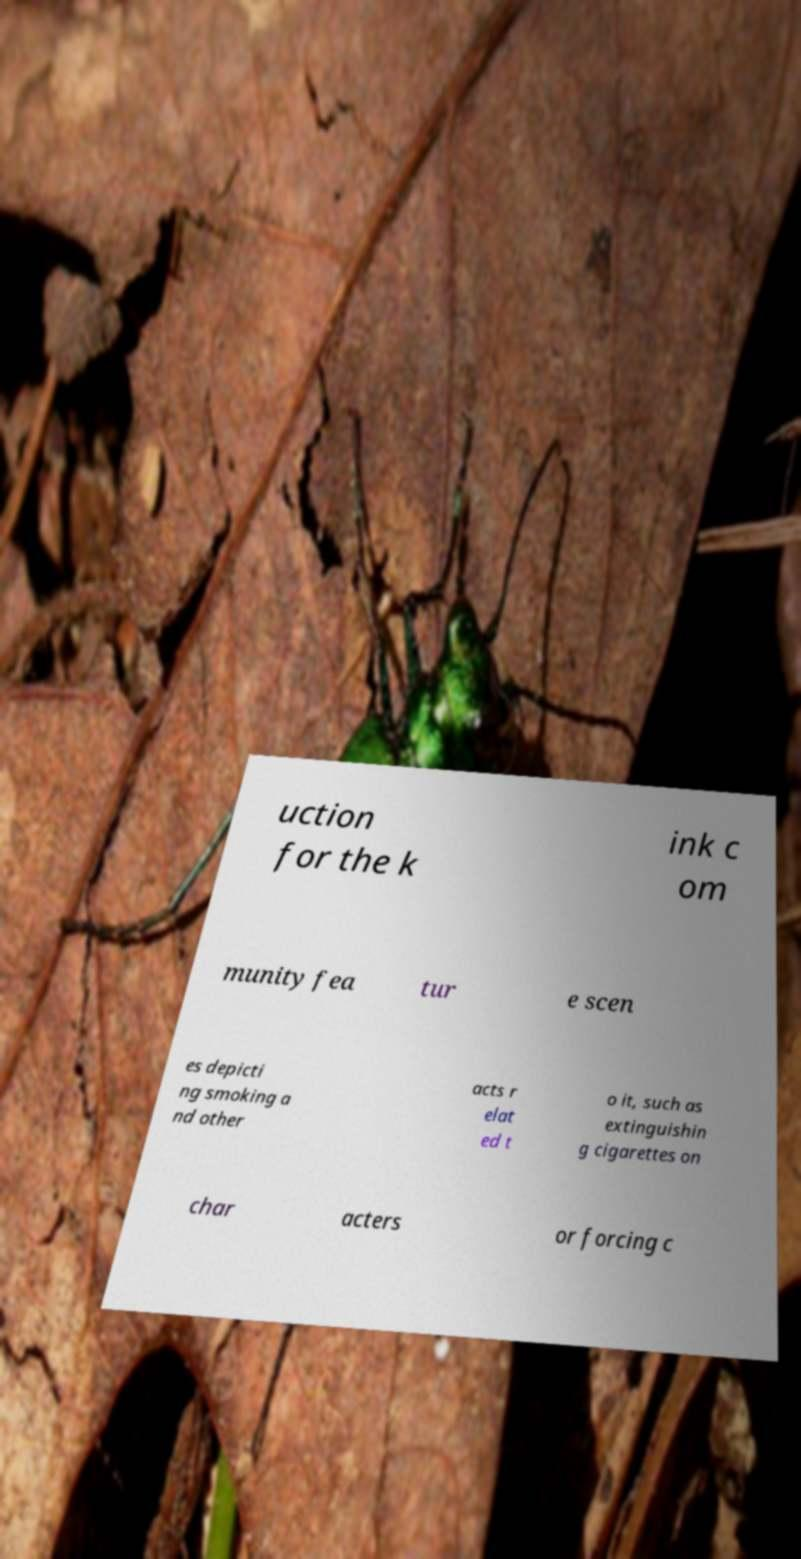There's text embedded in this image that I need extracted. Can you transcribe it verbatim? uction for the k ink c om munity fea tur e scen es depicti ng smoking a nd other acts r elat ed t o it, such as extinguishin g cigarettes on char acters or forcing c 